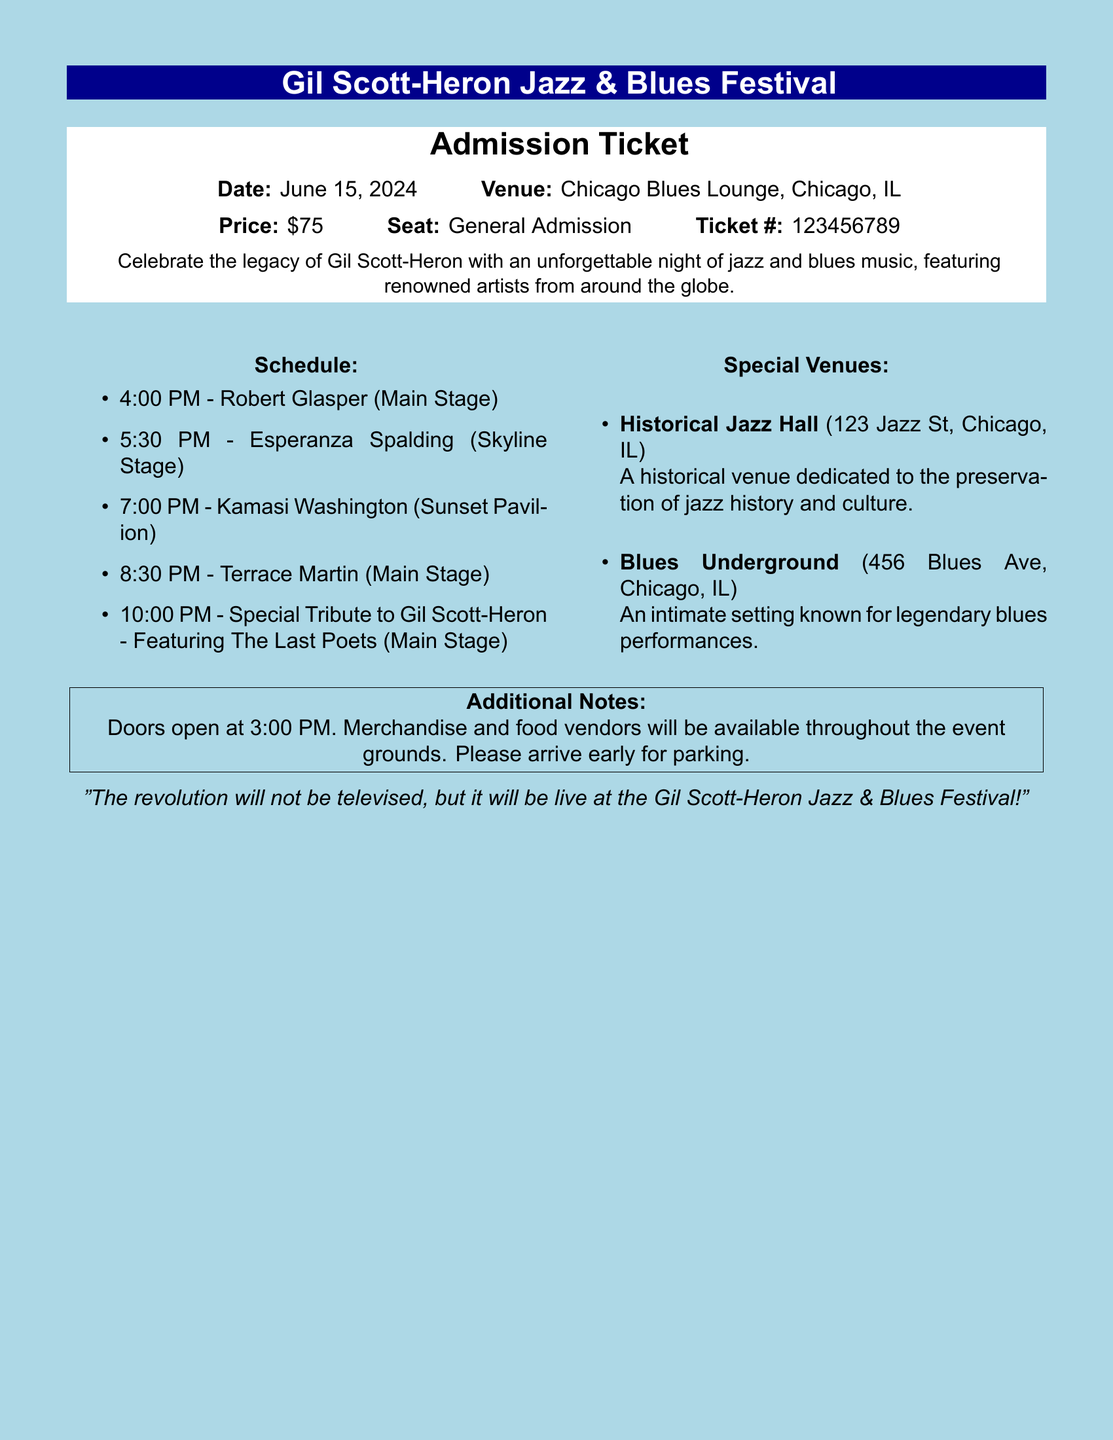what is the date of the festival? The date of the festival is explicitly stated in the document.
Answer: June 15, 2024 what is the venue for the festival? The venue is specified in the document as the location for the event.
Answer: Chicago Blues Lounge, Chicago, IL how much does an admission ticket cost? The price of the ticket is provided in the document.
Answer: $75 what time does the festival start? The document indicates when doors open for the event.
Answer: 3:00 PM who will perform at 7:00 PM? The schedule lists artists and their corresponding performance times.
Answer: Kamasi Washington where is the Historical Jazz Hall located? The document states the address of the Historical Jazz Hall.
Answer: 123 Jazz St, Chicago, IL which artist is featured for the special tribute? The document notes the special tribute artist for the festival.
Answer: The Last Poets how long is the performance by Robert Glasper? The schedule indicates the start and end time for each performance, allowing calculation of duration.
Answer: 1.5 hours what additional amenities are mentioned in the document? The document mentions services available to festival attendees.
Answer: Merchandise and food vendors 